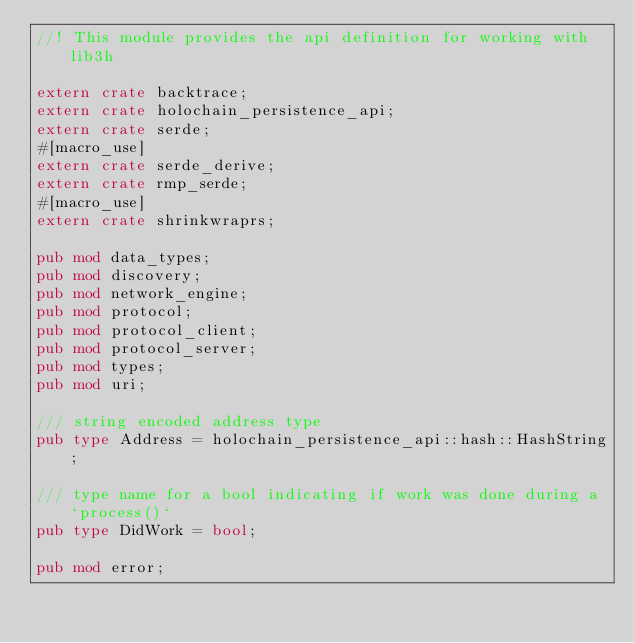<code> <loc_0><loc_0><loc_500><loc_500><_Rust_>//! This module provides the api definition for working with lib3h

extern crate backtrace;
extern crate holochain_persistence_api;
extern crate serde;
#[macro_use]
extern crate serde_derive;
extern crate rmp_serde;
#[macro_use]
extern crate shrinkwraprs;

pub mod data_types;
pub mod discovery;
pub mod network_engine;
pub mod protocol;
pub mod protocol_client;
pub mod protocol_server;
pub mod types;
pub mod uri;

/// string encoded address type
pub type Address = holochain_persistence_api::hash::HashString;

/// type name for a bool indicating if work was done during a `process()`
pub type DidWork = bool;

pub mod error;
</code> 